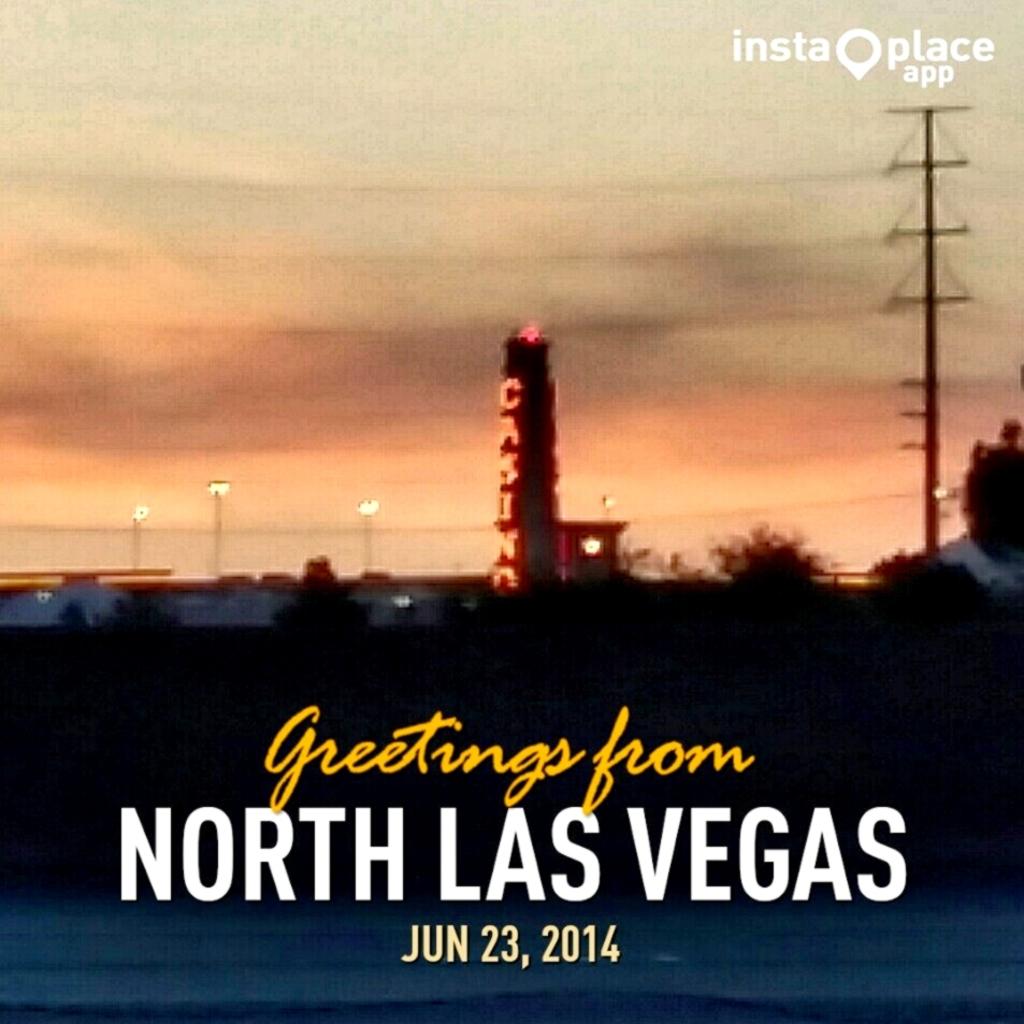What us city is mentioned in the greeting?
Provide a succinct answer. Las vegas. What month is the greeting from?
Your answer should be compact. June. 